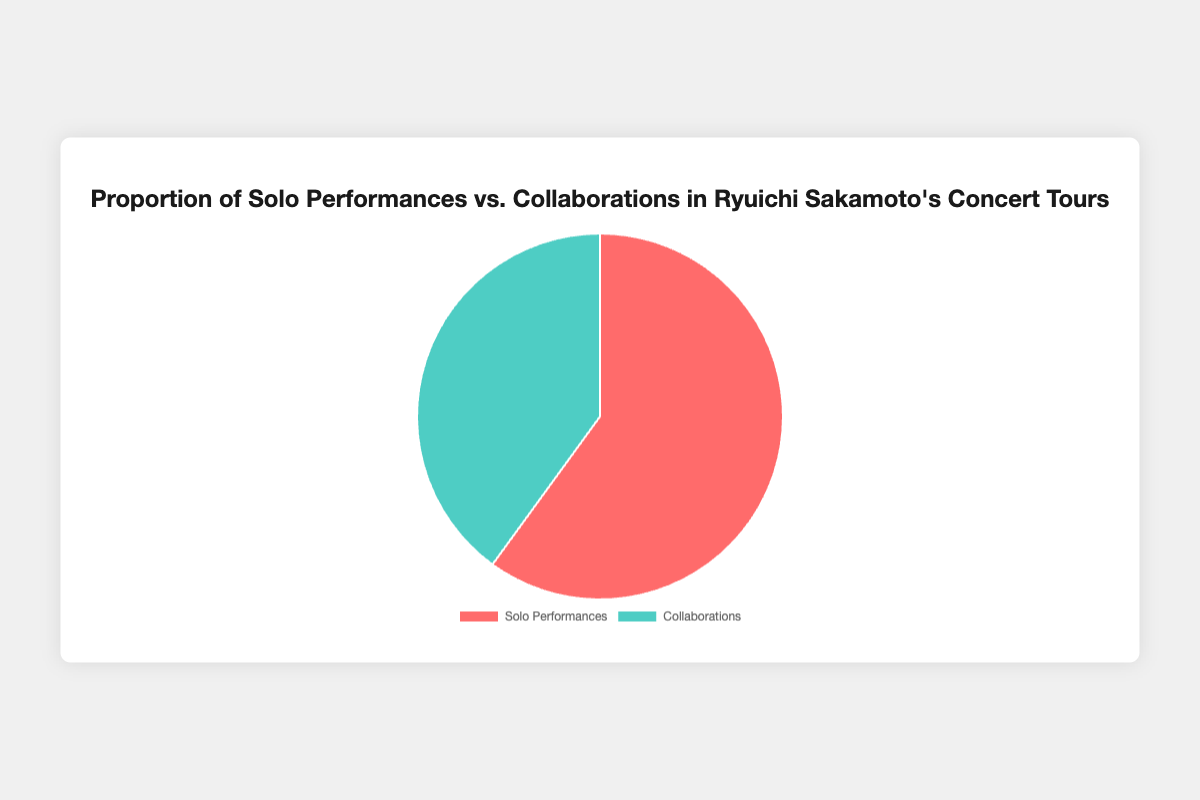What's the proportion of Solo Performances in Ryuichi Sakamoto's Concert Tours? The figure shows a pie chart which visually demonstrates the proportions. The Solo Performances section is represented as 60%.
Answer: 60% Which type of performance is more prominent in Ryuichi Sakamoto's Concert Tours? By comparing the two sections of the pie chart, we see that Solo Performances take up more space (60%) compared to Collaborations (40%).
Answer: Solo Performances What's the difference in proportion between Solo Performances and Collaborations? Subtract the proportion of Collaborations (40%) from Solo Performances (60%). This gives 60% - 40% = 20%.
Answer: 20% If a typical tour consists of 100 performances, how many would be Solo Performances and how many would be Collaborations? From the pie chart, 60% of 100 performances would be Solo and 40% would be Collaborations. Therefore, 60 performances would be Solo and 40 would be Collaborations.
Answer: Solo Performances: 60, Collaborations: 40 Are there more performances where Ryuichi Sakamoto collaborates with others or where he performs solo? The pie chart indicates that Solo Performances occupy a larger portion (60%) than Collaborations (40%), meaning there are more solo performances.
Answer: Solo Performances By how much do Solo Performances exceed Collaborations in percentage terms? The figure shows 60% for Solo Performances and 40% for Collaborations. The exceedance is calculated as 60% - 40% = 20%.
Answer: 20% If 150 concerts were planned, how would the performances be divided between Solo and Collaborations? Using the proportions from the pie chart: 60% of 150 concerts would be Solo, and 40% would be Collaborations. This translates to 90 Solo Performances and 60 Collaborations.
Answer: Solo Performances: 90, Collaborations: 60 Which section of the chart is represented by the red color? The pie chart visually represents Solo Performances in red.
Answer: Solo Performances What's the ratio of Solo Performances to Collaborations? Using the proportions from the pie chart, the ratio is 60:40. Simplified, this becomes 3:2.
Answer: 3:2 